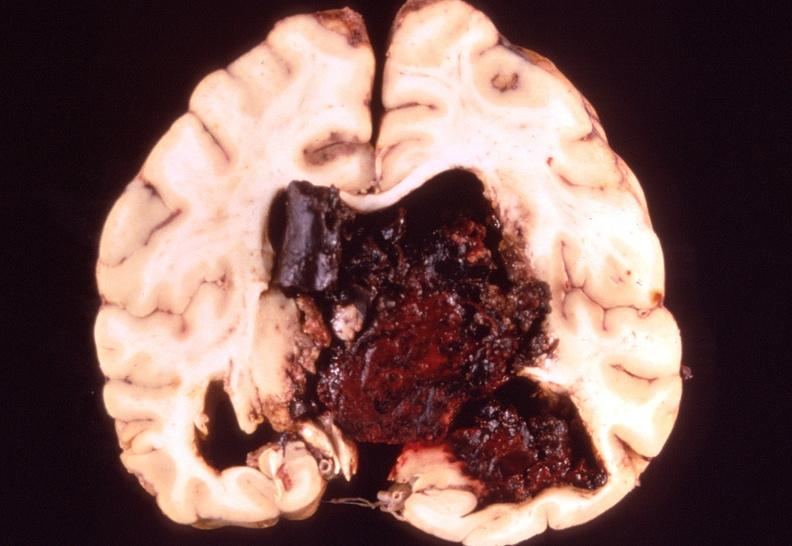what does this image show?
Answer the question using a single word or phrase. Brain 